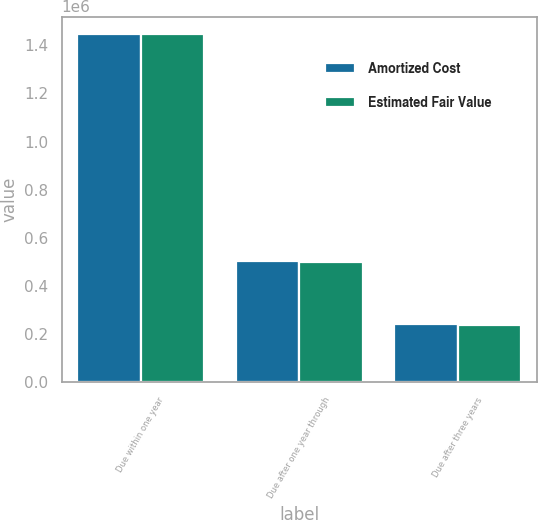Convert chart. <chart><loc_0><loc_0><loc_500><loc_500><stacked_bar_chart><ecel><fcel>Due within one year<fcel>Due after one year through<fcel>Due after three years<nl><fcel>Amortized Cost<fcel>1.44654e+06<fcel>502082<fcel>242037<nl><fcel>Estimated Fair Value<fcel>1.44613e+06<fcel>499592<fcel>238845<nl></chart> 